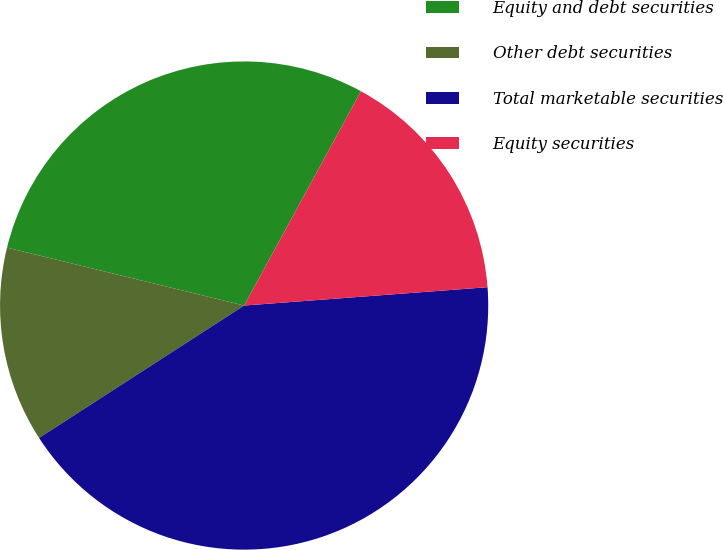Convert chart. <chart><loc_0><loc_0><loc_500><loc_500><pie_chart><fcel>Equity and debt securities<fcel>Other debt securities<fcel>Total marketable securities<fcel>Equity securities<nl><fcel>29.13%<fcel>12.94%<fcel>42.07%<fcel>15.86%<nl></chart> 